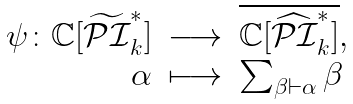<formula> <loc_0><loc_0><loc_500><loc_500>\begin{array} { r c l } \psi \colon \mathbb { C } [ \widetilde { \mathcal { P I } } ^ { * } _ { k } ] & \longrightarrow & \overline { \mathbb { C } [ \widehat { \mathcal { P I } } ^ { * } _ { k } ] } , \\ \alpha & \longmapsto & \sum _ { \beta \vdash \alpha } \beta \end{array}</formula> 